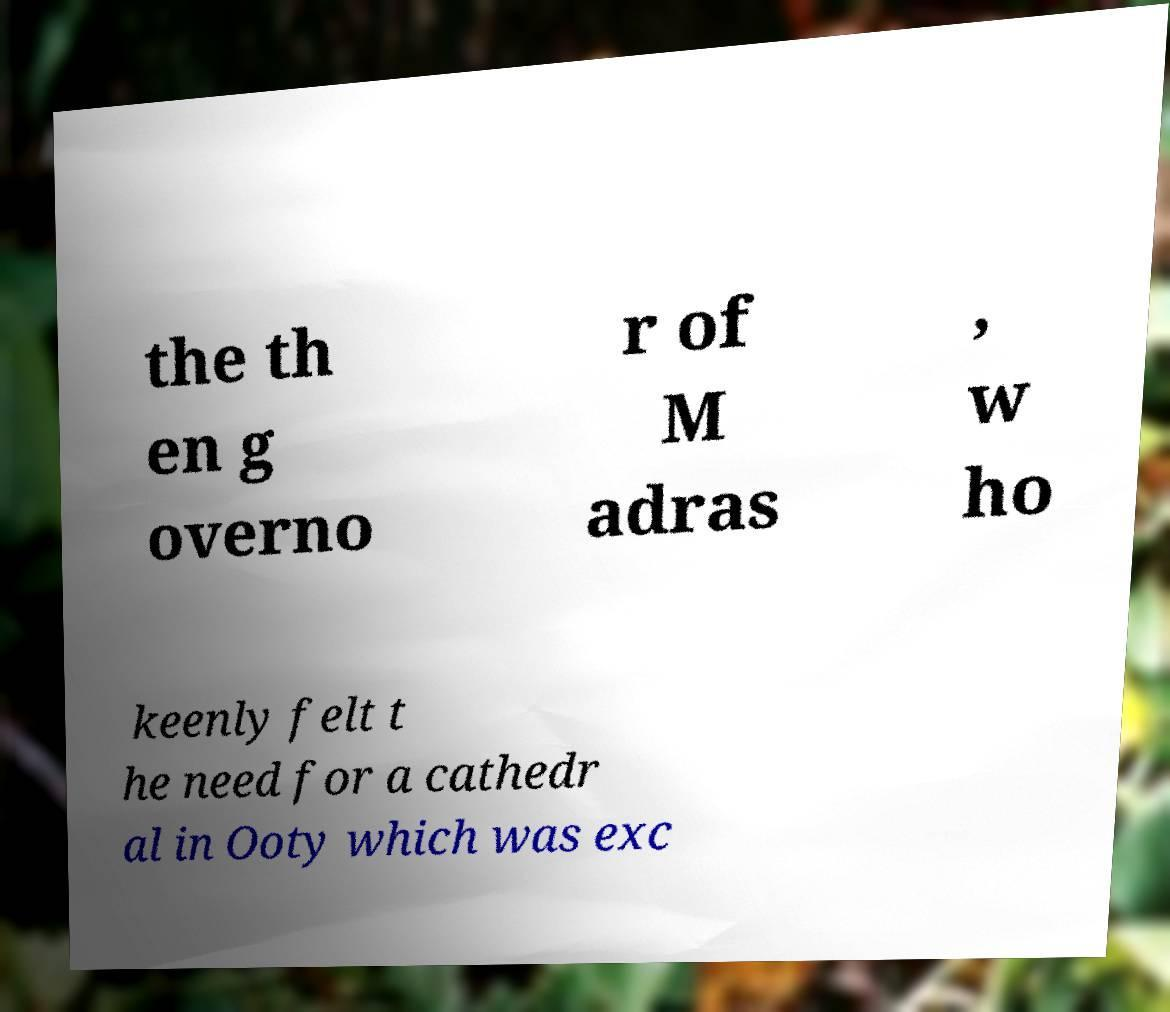Please identify and transcribe the text found in this image. the th en g overno r of M adras , w ho keenly felt t he need for a cathedr al in Ooty which was exc 